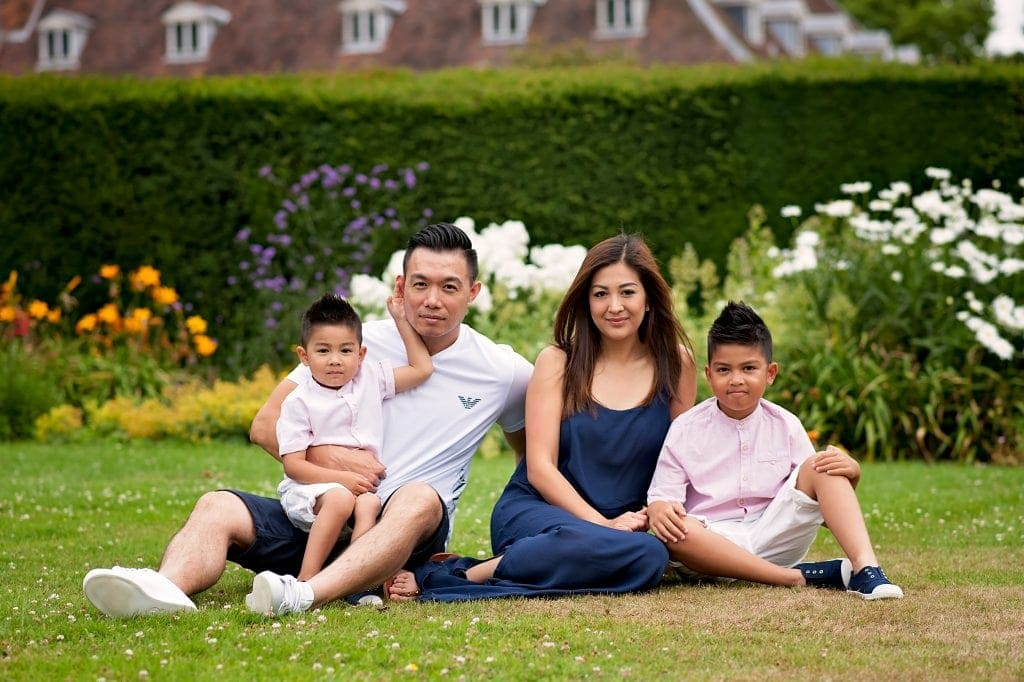What can be inferred about the family's relationship to each other based on their body language and positioning? The family appears to have a warm and affectionate bond, as represented by their body language and positioning. The man has the younger child seated comfortably on his lap, indicating a protective and loving nature, and the child looks relaxed and secure. The older child is sitting close to the woman, both exhibiting a relaxed posture and a slight lean towards each other, suggesting a warm and close relationship. The woman’s open posture, with her hands resting on her knees and not directly touching the children, may imply a nurturing role, overseeing the children's well-being while fostering independence. The close proximity and relaxed demeanors of all family members collectively suggest a close-knit family with mutual trust and affection. 